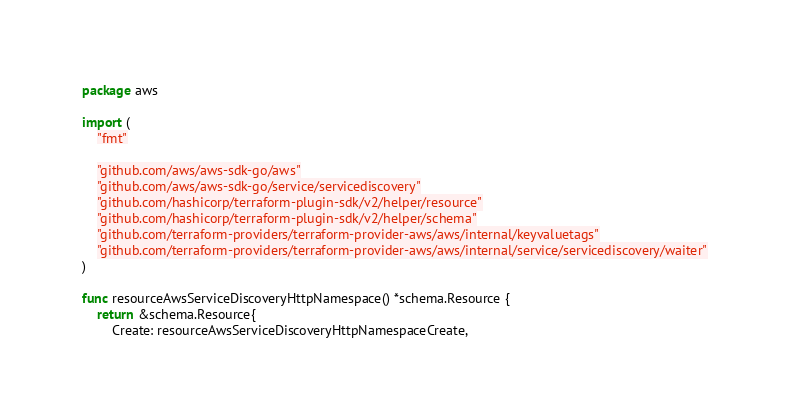<code> <loc_0><loc_0><loc_500><loc_500><_Go_>package aws

import (
	"fmt"

	"github.com/aws/aws-sdk-go/aws"
	"github.com/aws/aws-sdk-go/service/servicediscovery"
	"github.com/hashicorp/terraform-plugin-sdk/v2/helper/resource"
	"github.com/hashicorp/terraform-plugin-sdk/v2/helper/schema"
	"github.com/terraform-providers/terraform-provider-aws/aws/internal/keyvaluetags"
	"github.com/terraform-providers/terraform-provider-aws/aws/internal/service/servicediscovery/waiter"
)

func resourceAwsServiceDiscoveryHttpNamespace() *schema.Resource {
	return &schema.Resource{
		Create: resourceAwsServiceDiscoveryHttpNamespaceCreate,</code> 